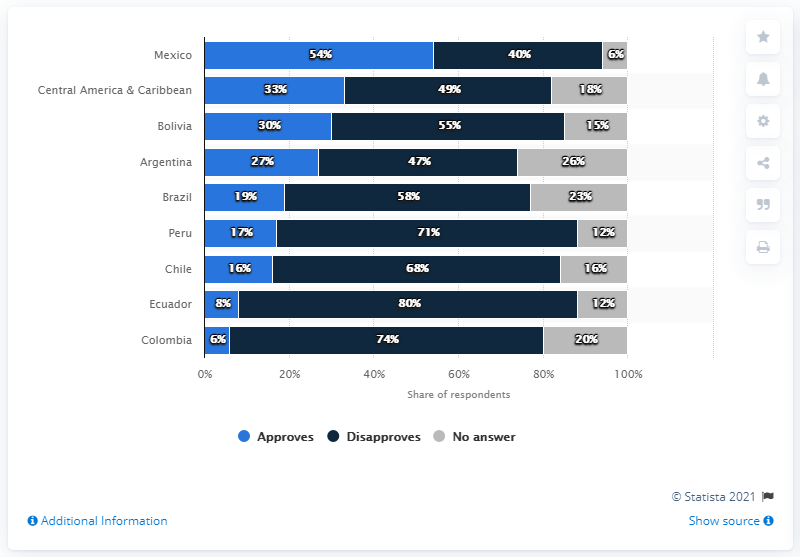Identify some key points in this picture. Approves percentage in Mexico is 54%. Ecuador has the largest gap between those who approve and those who disapprove of something. 